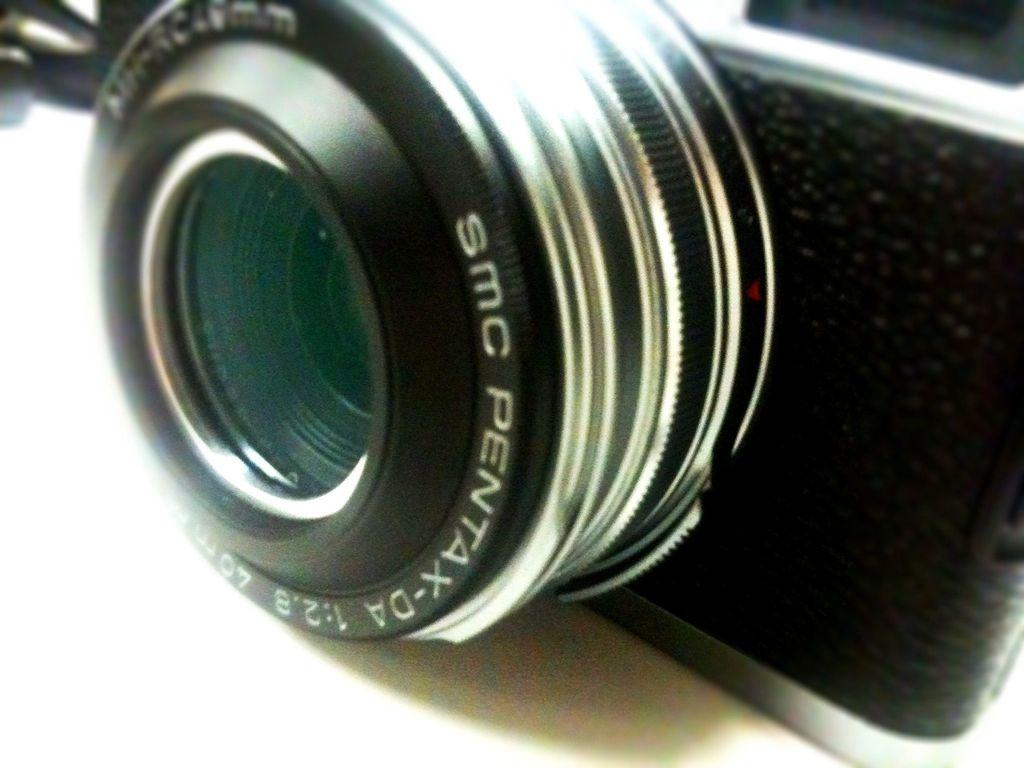What is the main object in the image? There is a camera in the image. Where is the camera positioned? The camera is placed on a platform. What type of shade is covering the camera in the image? There is no shade covering the camera in the image; it is placed on a platform without any visible coverings. 